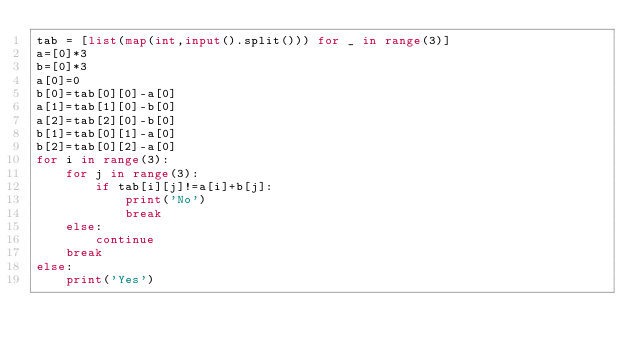Convert code to text. <code><loc_0><loc_0><loc_500><loc_500><_Python_>tab = [list(map(int,input().split())) for _ in range(3)]
a=[0]*3
b=[0]*3
a[0]=0
b[0]=tab[0][0]-a[0]
a[1]=tab[1][0]-b[0]
a[2]=tab[2][0]-b[0]
b[1]=tab[0][1]-a[0]
b[2]=tab[0][2]-a[0]
for i in range(3):
    for j in range(3):
        if tab[i][j]!=a[i]+b[j]:
            print('No')
            break
    else:
        continue
    break
else:
    print('Yes')
</code> 